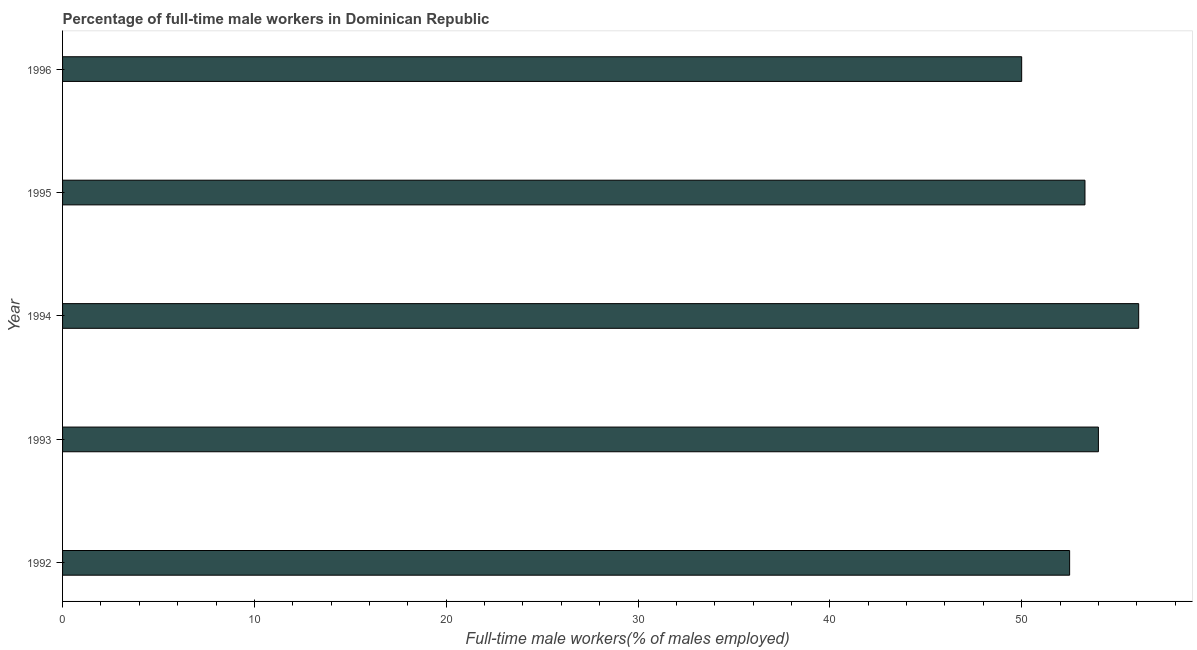Does the graph contain grids?
Your response must be concise. No. What is the title of the graph?
Make the answer very short. Percentage of full-time male workers in Dominican Republic. What is the label or title of the X-axis?
Give a very brief answer. Full-time male workers(% of males employed). What is the label or title of the Y-axis?
Your answer should be compact. Year. What is the percentage of full-time male workers in 1996?
Provide a short and direct response. 50. Across all years, what is the maximum percentage of full-time male workers?
Provide a succinct answer. 56.1. In which year was the percentage of full-time male workers minimum?
Offer a terse response. 1996. What is the sum of the percentage of full-time male workers?
Your answer should be compact. 265.9. What is the difference between the percentage of full-time male workers in 1992 and 1996?
Make the answer very short. 2.5. What is the average percentage of full-time male workers per year?
Provide a succinct answer. 53.18. What is the median percentage of full-time male workers?
Make the answer very short. 53.3. In how many years, is the percentage of full-time male workers greater than 46 %?
Provide a succinct answer. 5. Do a majority of the years between 1993 and 1995 (inclusive) have percentage of full-time male workers greater than 16 %?
Make the answer very short. Yes. Is the difference between the percentage of full-time male workers in 1993 and 1994 greater than the difference between any two years?
Make the answer very short. No. Is the sum of the percentage of full-time male workers in 1993 and 1996 greater than the maximum percentage of full-time male workers across all years?
Give a very brief answer. Yes. How many bars are there?
Your answer should be very brief. 5. How many years are there in the graph?
Provide a succinct answer. 5. What is the difference between two consecutive major ticks on the X-axis?
Keep it short and to the point. 10. What is the Full-time male workers(% of males employed) of 1992?
Give a very brief answer. 52.5. What is the Full-time male workers(% of males employed) in 1993?
Provide a succinct answer. 54. What is the Full-time male workers(% of males employed) in 1994?
Provide a succinct answer. 56.1. What is the Full-time male workers(% of males employed) of 1995?
Keep it short and to the point. 53.3. What is the Full-time male workers(% of males employed) of 1996?
Your answer should be compact. 50. What is the difference between the Full-time male workers(% of males employed) in 1992 and 1993?
Your response must be concise. -1.5. What is the difference between the Full-time male workers(% of males employed) in 1992 and 1995?
Give a very brief answer. -0.8. What is the difference between the Full-time male workers(% of males employed) in 1992 and 1996?
Your answer should be very brief. 2.5. What is the difference between the Full-time male workers(% of males employed) in 1993 and 1994?
Offer a terse response. -2.1. What is the difference between the Full-time male workers(% of males employed) in 1993 and 1996?
Give a very brief answer. 4. What is the difference between the Full-time male workers(% of males employed) in 1994 and 1995?
Your answer should be compact. 2.8. What is the ratio of the Full-time male workers(% of males employed) in 1992 to that in 1993?
Keep it short and to the point. 0.97. What is the ratio of the Full-time male workers(% of males employed) in 1992 to that in 1994?
Keep it short and to the point. 0.94. What is the ratio of the Full-time male workers(% of males employed) in 1992 to that in 1996?
Your answer should be compact. 1.05. What is the ratio of the Full-time male workers(% of males employed) in 1993 to that in 1994?
Provide a succinct answer. 0.96. What is the ratio of the Full-time male workers(% of males employed) in 1993 to that in 1996?
Keep it short and to the point. 1.08. What is the ratio of the Full-time male workers(% of males employed) in 1994 to that in 1995?
Make the answer very short. 1.05. What is the ratio of the Full-time male workers(% of males employed) in 1994 to that in 1996?
Your answer should be compact. 1.12. What is the ratio of the Full-time male workers(% of males employed) in 1995 to that in 1996?
Your response must be concise. 1.07. 